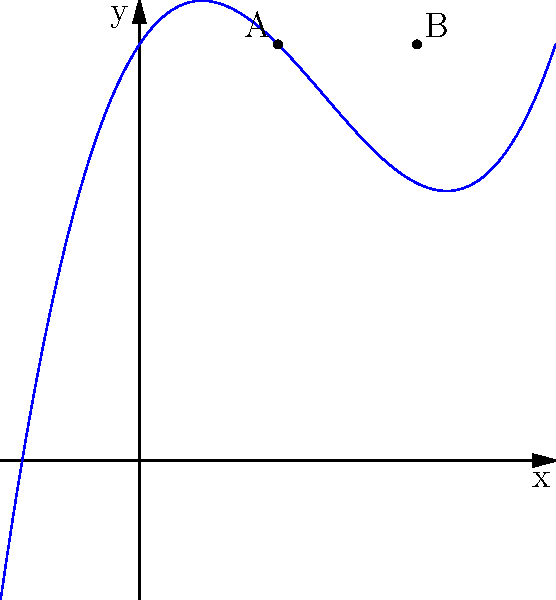As an aspiring archaeologist, you've uncovered an artifact with a unique curved profile. The shape can be modeled by a cubic polynomial function. Given that the curve passes through points A(1,3) and B(2,3), and the y-intercept is 3, determine the polynomial function f(x) that represents the artifact's profile. Let's approach this step-by-step:

1) The general form of a cubic polynomial is:
   $$f(x) = ax^3 + bx^2 + cx + d$$

2) We know the y-intercept is 3, so:
   $$f(0) = d = 3$$

3) The curve passes through A(1,3) and B(2,3), so:
   $$f(1) = a + b + c + 3 = 3$$
   $$f(2) = 8a + 4b + 2c + 3 = 3$$

4) From f(1) = 3:
   $$a + b + c = 0$$

5) From f(2) = 3:
   $$8a + 4b + 2c = 0$$

6) Subtracting equation 4 from equation 5:
   $$7a + 3b + c = 0$$

7) From steps 4 and 6, we have two equations:
   $$a + b + c = 0$$
   $$7a + 3b + c = 0$$

8) Subtracting these:
   $$6a + 2b = 0$$
   $$3a + b = 0$$
   $$b = -3a$$

9) Substituting into $$a + b + c = 0$$:
   $$a - 3a + c = 0$$
   $$c = 2a$$

10) Now we have:
    $$f(x) = ax^3 - 3ax^2 + 2ax + 3$$

11) To find a, we can use the fact that the curve is symmetric about x = 1.5 (midpoint of A and B). The derivative at this point should be 0:
    $$f'(x) = 3ax^2 - 6ax + 2a$$
    $$f'(1.5) = 3a(1.5)^2 - 6a(1.5) + 2a = 0$$
    $$6.75a - 9a + 2a = -0.25a = 0$$
    $$a = 0.5$$

12) Therefore, the final function is:
    $$f(x) = 0.5x^3 - 1.5x^2 + x + 3$$
Answer: $$f(x) = 0.5x^3 - 1.5x^2 + x + 3$$ 